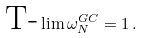<formula> <loc_0><loc_0><loc_500><loc_500>\text {T-} \lim \mathcal { \omega } _ { N } ^ { G C } = 1 \, .</formula> 